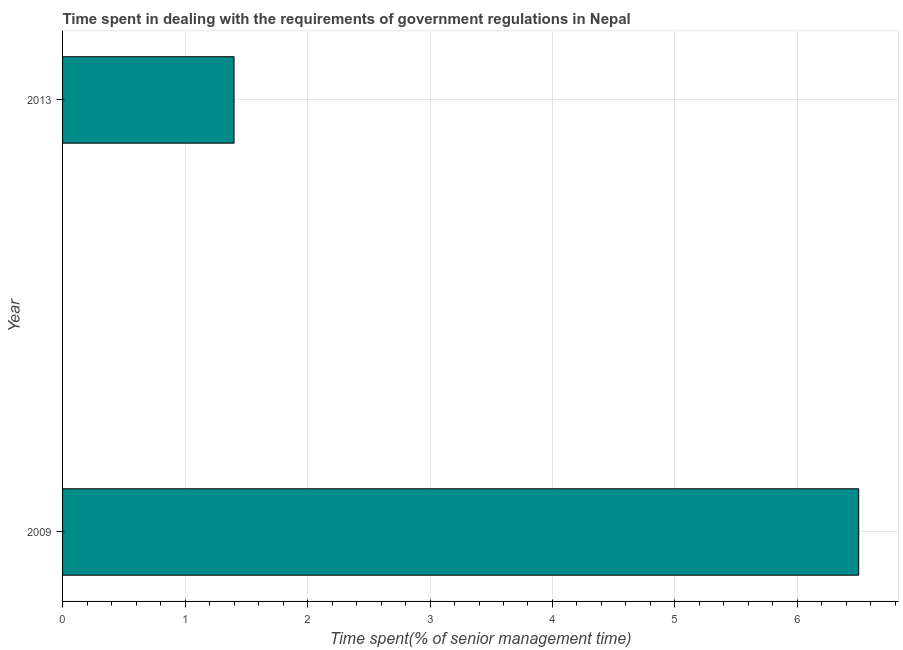Does the graph contain grids?
Offer a very short reply. Yes. What is the title of the graph?
Your answer should be very brief. Time spent in dealing with the requirements of government regulations in Nepal. What is the label or title of the X-axis?
Your answer should be compact. Time spent(% of senior management time). What is the label or title of the Y-axis?
Offer a very short reply. Year. In which year was the time spent in dealing with government regulations minimum?
Offer a very short reply. 2013. What is the sum of the time spent in dealing with government regulations?
Your answer should be compact. 7.9. What is the average time spent in dealing with government regulations per year?
Make the answer very short. 3.95. What is the median time spent in dealing with government regulations?
Provide a succinct answer. 3.95. What is the ratio of the time spent in dealing with government regulations in 2009 to that in 2013?
Give a very brief answer. 4.64. Is the time spent in dealing with government regulations in 2009 less than that in 2013?
Ensure brevity in your answer.  No. In how many years, is the time spent in dealing with government regulations greater than the average time spent in dealing with government regulations taken over all years?
Offer a terse response. 1. How many bars are there?
Your answer should be compact. 2. Are all the bars in the graph horizontal?
Provide a short and direct response. Yes. Are the values on the major ticks of X-axis written in scientific E-notation?
Ensure brevity in your answer.  No. What is the difference between the Time spent(% of senior management time) in 2009 and 2013?
Your answer should be very brief. 5.1. What is the ratio of the Time spent(% of senior management time) in 2009 to that in 2013?
Your answer should be very brief. 4.64. 